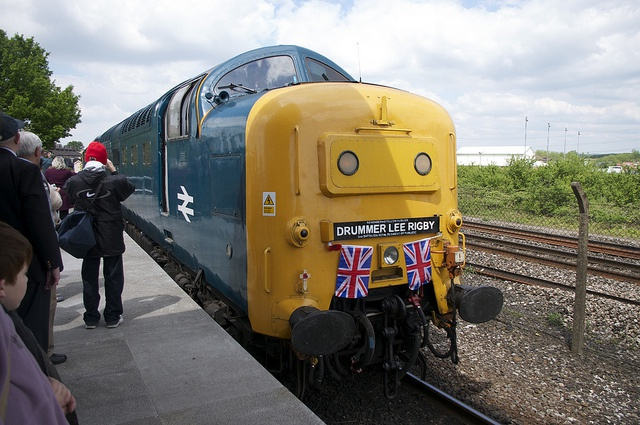Describe the objects in this image and their specific colors. I can see train in lightgray, black, olive, gray, and blue tones, people in lightgray, black, gray, and darkgray tones, people in lightgray, gray, black, and purple tones, people in lightgray, black, gray, and darkgray tones, and people in lightgray, gray, black, darkgray, and maroon tones in this image. 